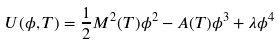Convert formula to latex. <formula><loc_0><loc_0><loc_500><loc_500>U ( \phi , T ) = \frac { 1 } { 2 } M ^ { 2 } ( T ) \phi ^ { 2 } - A ( T ) \phi ^ { 3 } + \lambda \phi ^ { 4 }</formula> 